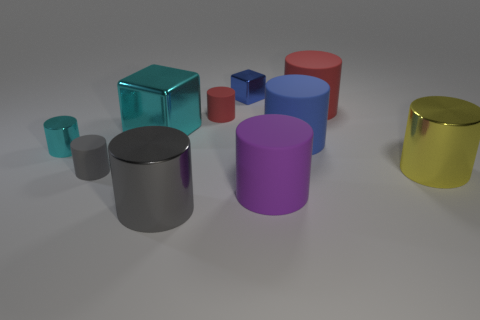What is the shape of the metallic object that is the same color as the small metallic cylinder?
Provide a succinct answer. Cube. There is a large yellow metallic cylinder; what number of large blocks are behind it?
Your answer should be compact. 1. Does the gray metal thing have the same shape as the large red matte object?
Ensure brevity in your answer.  Yes. How many matte cylinders are both on the right side of the large blue object and in front of the big cyan thing?
Your answer should be compact. 0. What number of objects are either blue cylinders or big cylinders behind the large blue matte object?
Provide a short and direct response. 2. Is the number of small purple things greater than the number of cyan metallic things?
Keep it short and to the point. No. The cyan thing that is on the left side of the big cube has what shape?
Make the answer very short. Cylinder. How many other large objects are the same shape as the big red thing?
Make the answer very short. 4. What size is the metallic cylinder behind the large yellow metallic object in front of the tiny metallic cylinder?
Provide a short and direct response. Small. How many cyan objects are either metallic objects or small rubber objects?
Your response must be concise. 2. 